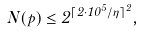Convert formula to latex. <formula><loc_0><loc_0><loc_500><loc_500>N ( p ) \leq 2 ^ { \lceil 2 \cdot 1 0 ^ { 5 } / \eta \rceil ^ { 2 } } ,</formula> 